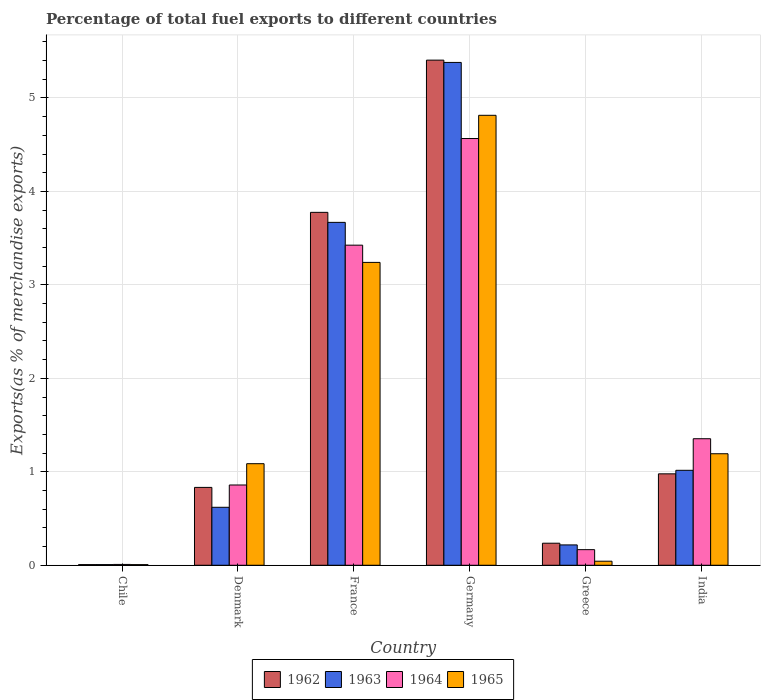How many different coloured bars are there?
Your answer should be compact. 4. Are the number of bars per tick equal to the number of legend labels?
Provide a short and direct response. Yes. Are the number of bars on each tick of the X-axis equal?
Your answer should be compact. Yes. How many bars are there on the 4th tick from the left?
Keep it short and to the point. 4. How many bars are there on the 6th tick from the right?
Provide a short and direct response. 4. What is the label of the 2nd group of bars from the left?
Keep it short and to the point. Denmark. In how many cases, is the number of bars for a given country not equal to the number of legend labels?
Offer a terse response. 0. What is the percentage of exports to different countries in 1962 in Chile?
Keep it short and to the point. 0.01. Across all countries, what is the maximum percentage of exports to different countries in 1964?
Give a very brief answer. 4.57. Across all countries, what is the minimum percentage of exports to different countries in 1962?
Offer a terse response. 0.01. In which country was the percentage of exports to different countries in 1962 maximum?
Give a very brief answer. Germany. What is the total percentage of exports to different countries in 1964 in the graph?
Ensure brevity in your answer.  10.38. What is the difference between the percentage of exports to different countries in 1964 in Chile and that in France?
Give a very brief answer. -3.42. What is the difference between the percentage of exports to different countries in 1965 in Greece and the percentage of exports to different countries in 1964 in India?
Provide a succinct answer. -1.31. What is the average percentage of exports to different countries in 1962 per country?
Provide a succinct answer. 1.87. What is the difference between the percentage of exports to different countries of/in 1965 and percentage of exports to different countries of/in 1962 in France?
Make the answer very short. -0.54. In how many countries, is the percentage of exports to different countries in 1962 greater than 3.4 %?
Your answer should be very brief. 2. What is the ratio of the percentage of exports to different countries in 1965 in France to that in Greece?
Ensure brevity in your answer.  74.69. Is the percentage of exports to different countries in 1962 in Denmark less than that in Germany?
Provide a short and direct response. Yes. What is the difference between the highest and the second highest percentage of exports to different countries in 1964?
Offer a very short reply. -2.07. What is the difference between the highest and the lowest percentage of exports to different countries in 1965?
Your answer should be compact. 4.81. In how many countries, is the percentage of exports to different countries in 1963 greater than the average percentage of exports to different countries in 1963 taken over all countries?
Your response must be concise. 2. Is the sum of the percentage of exports to different countries in 1963 in France and Germany greater than the maximum percentage of exports to different countries in 1964 across all countries?
Offer a terse response. Yes. What does the 4th bar from the left in Greece represents?
Your answer should be very brief. 1965. What does the 3rd bar from the right in Germany represents?
Offer a terse response. 1963. How many bars are there?
Offer a terse response. 24. Are the values on the major ticks of Y-axis written in scientific E-notation?
Keep it short and to the point. No. Does the graph contain grids?
Your response must be concise. Yes. Where does the legend appear in the graph?
Your answer should be compact. Bottom center. How many legend labels are there?
Make the answer very short. 4. What is the title of the graph?
Keep it short and to the point. Percentage of total fuel exports to different countries. What is the label or title of the Y-axis?
Provide a short and direct response. Exports(as % of merchandise exports). What is the Exports(as % of merchandise exports) in 1962 in Chile?
Keep it short and to the point. 0.01. What is the Exports(as % of merchandise exports) of 1963 in Chile?
Your response must be concise. 0.01. What is the Exports(as % of merchandise exports) of 1964 in Chile?
Give a very brief answer. 0.01. What is the Exports(as % of merchandise exports) of 1965 in Chile?
Offer a very short reply. 0.01. What is the Exports(as % of merchandise exports) in 1962 in Denmark?
Provide a succinct answer. 0.83. What is the Exports(as % of merchandise exports) of 1963 in Denmark?
Offer a terse response. 0.62. What is the Exports(as % of merchandise exports) of 1964 in Denmark?
Ensure brevity in your answer.  0.86. What is the Exports(as % of merchandise exports) of 1965 in Denmark?
Your answer should be very brief. 1.09. What is the Exports(as % of merchandise exports) in 1962 in France?
Your response must be concise. 3.78. What is the Exports(as % of merchandise exports) of 1963 in France?
Provide a short and direct response. 3.67. What is the Exports(as % of merchandise exports) of 1964 in France?
Provide a short and direct response. 3.43. What is the Exports(as % of merchandise exports) of 1965 in France?
Your answer should be compact. 3.24. What is the Exports(as % of merchandise exports) in 1962 in Germany?
Offer a very short reply. 5.4. What is the Exports(as % of merchandise exports) in 1963 in Germany?
Provide a short and direct response. 5.38. What is the Exports(as % of merchandise exports) in 1964 in Germany?
Your answer should be compact. 4.57. What is the Exports(as % of merchandise exports) in 1965 in Germany?
Provide a succinct answer. 4.81. What is the Exports(as % of merchandise exports) in 1962 in Greece?
Ensure brevity in your answer.  0.24. What is the Exports(as % of merchandise exports) of 1963 in Greece?
Ensure brevity in your answer.  0.22. What is the Exports(as % of merchandise exports) in 1964 in Greece?
Make the answer very short. 0.17. What is the Exports(as % of merchandise exports) of 1965 in Greece?
Your answer should be very brief. 0.04. What is the Exports(as % of merchandise exports) of 1962 in India?
Your answer should be compact. 0.98. What is the Exports(as % of merchandise exports) of 1963 in India?
Keep it short and to the point. 1.02. What is the Exports(as % of merchandise exports) of 1964 in India?
Offer a terse response. 1.35. What is the Exports(as % of merchandise exports) of 1965 in India?
Your response must be concise. 1.19. Across all countries, what is the maximum Exports(as % of merchandise exports) in 1962?
Provide a short and direct response. 5.4. Across all countries, what is the maximum Exports(as % of merchandise exports) of 1963?
Your response must be concise. 5.38. Across all countries, what is the maximum Exports(as % of merchandise exports) of 1964?
Offer a very short reply. 4.57. Across all countries, what is the maximum Exports(as % of merchandise exports) of 1965?
Provide a succinct answer. 4.81. Across all countries, what is the minimum Exports(as % of merchandise exports) of 1962?
Ensure brevity in your answer.  0.01. Across all countries, what is the minimum Exports(as % of merchandise exports) of 1963?
Your answer should be compact. 0.01. Across all countries, what is the minimum Exports(as % of merchandise exports) in 1964?
Your answer should be very brief. 0.01. Across all countries, what is the minimum Exports(as % of merchandise exports) in 1965?
Your response must be concise. 0.01. What is the total Exports(as % of merchandise exports) in 1962 in the graph?
Make the answer very short. 11.24. What is the total Exports(as % of merchandise exports) of 1963 in the graph?
Keep it short and to the point. 10.91. What is the total Exports(as % of merchandise exports) of 1964 in the graph?
Provide a short and direct response. 10.38. What is the total Exports(as % of merchandise exports) of 1965 in the graph?
Ensure brevity in your answer.  10.39. What is the difference between the Exports(as % of merchandise exports) of 1962 in Chile and that in Denmark?
Provide a short and direct response. -0.83. What is the difference between the Exports(as % of merchandise exports) of 1963 in Chile and that in Denmark?
Keep it short and to the point. -0.61. What is the difference between the Exports(as % of merchandise exports) of 1964 in Chile and that in Denmark?
Make the answer very short. -0.85. What is the difference between the Exports(as % of merchandise exports) in 1965 in Chile and that in Denmark?
Your answer should be very brief. -1.08. What is the difference between the Exports(as % of merchandise exports) in 1962 in Chile and that in France?
Your answer should be compact. -3.77. What is the difference between the Exports(as % of merchandise exports) in 1963 in Chile and that in France?
Offer a very short reply. -3.66. What is the difference between the Exports(as % of merchandise exports) in 1964 in Chile and that in France?
Give a very brief answer. -3.42. What is the difference between the Exports(as % of merchandise exports) of 1965 in Chile and that in France?
Your answer should be very brief. -3.23. What is the difference between the Exports(as % of merchandise exports) of 1962 in Chile and that in Germany?
Your answer should be compact. -5.4. What is the difference between the Exports(as % of merchandise exports) in 1963 in Chile and that in Germany?
Your response must be concise. -5.37. What is the difference between the Exports(as % of merchandise exports) of 1964 in Chile and that in Germany?
Provide a succinct answer. -4.56. What is the difference between the Exports(as % of merchandise exports) in 1965 in Chile and that in Germany?
Your answer should be compact. -4.81. What is the difference between the Exports(as % of merchandise exports) in 1962 in Chile and that in Greece?
Your answer should be very brief. -0.23. What is the difference between the Exports(as % of merchandise exports) in 1963 in Chile and that in Greece?
Offer a terse response. -0.21. What is the difference between the Exports(as % of merchandise exports) in 1964 in Chile and that in Greece?
Provide a short and direct response. -0.16. What is the difference between the Exports(as % of merchandise exports) of 1965 in Chile and that in Greece?
Offer a terse response. -0.04. What is the difference between the Exports(as % of merchandise exports) in 1962 in Chile and that in India?
Offer a very short reply. -0.97. What is the difference between the Exports(as % of merchandise exports) in 1963 in Chile and that in India?
Give a very brief answer. -1.01. What is the difference between the Exports(as % of merchandise exports) in 1964 in Chile and that in India?
Offer a very short reply. -1.34. What is the difference between the Exports(as % of merchandise exports) of 1965 in Chile and that in India?
Offer a terse response. -1.19. What is the difference between the Exports(as % of merchandise exports) in 1962 in Denmark and that in France?
Offer a terse response. -2.94. What is the difference between the Exports(as % of merchandise exports) in 1963 in Denmark and that in France?
Offer a very short reply. -3.05. What is the difference between the Exports(as % of merchandise exports) in 1964 in Denmark and that in France?
Offer a terse response. -2.57. What is the difference between the Exports(as % of merchandise exports) of 1965 in Denmark and that in France?
Keep it short and to the point. -2.15. What is the difference between the Exports(as % of merchandise exports) in 1962 in Denmark and that in Germany?
Provide a short and direct response. -4.57. What is the difference between the Exports(as % of merchandise exports) in 1963 in Denmark and that in Germany?
Make the answer very short. -4.76. What is the difference between the Exports(as % of merchandise exports) in 1964 in Denmark and that in Germany?
Give a very brief answer. -3.71. What is the difference between the Exports(as % of merchandise exports) in 1965 in Denmark and that in Germany?
Provide a short and direct response. -3.73. What is the difference between the Exports(as % of merchandise exports) of 1962 in Denmark and that in Greece?
Your response must be concise. 0.6. What is the difference between the Exports(as % of merchandise exports) in 1963 in Denmark and that in Greece?
Ensure brevity in your answer.  0.4. What is the difference between the Exports(as % of merchandise exports) in 1964 in Denmark and that in Greece?
Your answer should be very brief. 0.69. What is the difference between the Exports(as % of merchandise exports) in 1965 in Denmark and that in Greece?
Offer a very short reply. 1.04. What is the difference between the Exports(as % of merchandise exports) in 1962 in Denmark and that in India?
Provide a succinct answer. -0.14. What is the difference between the Exports(as % of merchandise exports) in 1963 in Denmark and that in India?
Offer a terse response. -0.4. What is the difference between the Exports(as % of merchandise exports) in 1964 in Denmark and that in India?
Provide a short and direct response. -0.49. What is the difference between the Exports(as % of merchandise exports) in 1965 in Denmark and that in India?
Give a very brief answer. -0.11. What is the difference between the Exports(as % of merchandise exports) of 1962 in France and that in Germany?
Give a very brief answer. -1.63. What is the difference between the Exports(as % of merchandise exports) in 1963 in France and that in Germany?
Keep it short and to the point. -1.71. What is the difference between the Exports(as % of merchandise exports) of 1964 in France and that in Germany?
Ensure brevity in your answer.  -1.14. What is the difference between the Exports(as % of merchandise exports) in 1965 in France and that in Germany?
Make the answer very short. -1.57. What is the difference between the Exports(as % of merchandise exports) of 1962 in France and that in Greece?
Ensure brevity in your answer.  3.54. What is the difference between the Exports(as % of merchandise exports) of 1963 in France and that in Greece?
Your answer should be very brief. 3.45. What is the difference between the Exports(as % of merchandise exports) of 1964 in France and that in Greece?
Keep it short and to the point. 3.26. What is the difference between the Exports(as % of merchandise exports) of 1965 in France and that in Greece?
Ensure brevity in your answer.  3.2. What is the difference between the Exports(as % of merchandise exports) of 1962 in France and that in India?
Offer a very short reply. 2.8. What is the difference between the Exports(as % of merchandise exports) of 1963 in France and that in India?
Ensure brevity in your answer.  2.65. What is the difference between the Exports(as % of merchandise exports) of 1964 in France and that in India?
Your answer should be compact. 2.07. What is the difference between the Exports(as % of merchandise exports) in 1965 in France and that in India?
Your answer should be compact. 2.05. What is the difference between the Exports(as % of merchandise exports) of 1962 in Germany and that in Greece?
Provide a short and direct response. 5.17. What is the difference between the Exports(as % of merchandise exports) of 1963 in Germany and that in Greece?
Give a very brief answer. 5.16. What is the difference between the Exports(as % of merchandise exports) in 1964 in Germany and that in Greece?
Provide a short and direct response. 4.4. What is the difference between the Exports(as % of merchandise exports) in 1965 in Germany and that in Greece?
Give a very brief answer. 4.77. What is the difference between the Exports(as % of merchandise exports) in 1962 in Germany and that in India?
Offer a terse response. 4.43. What is the difference between the Exports(as % of merchandise exports) in 1963 in Germany and that in India?
Provide a short and direct response. 4.36. What is the difference between the Exports(as % of merchandise exports) of 1964 in Germany and that in India?
Provide a short and direct response. 3.21. What is the difference between the Exports(as % of merchandise exports) of 1965 in Germany and that in India?
Provide a succinct answer. 3.62. What is the difference between the Exports(as % of merchandise exports) of 1962 in Greece and that in India?
Make the answer very short. -0.74. What is the difference between the Exports(as % of merchandise exports) of 1963 in Greece and that in India?
Make the answer very short. -0.8. What is the difference between the Exports(as % of merchandise exports) in 1964 in Greece and that in India?
Ensure brevity in your answer.  -1.19. What is the difference between the Exports(as % of merchandise exports) of 1965 in Greece and that in India?
Offer a terse response. -1.15. What is the difference between the Exports(as % of merchandise exports) in 1962 in Chile and the Exports(as % of merchandise exports) in 1963 in Denmark?
Your answer should be compact. -0.61. What is the difference between the Exports(as % of merchandise exports) of 1962 in Chile and the Exports(as % of merchandise exports) of 1964 in Denmark?
Provide a succinct answer. -0.85. What is the difference between the Exports(as % of merchandise exports) in 1962 in Chile and the Exports(as % of merchandise exports) in 1965 in Denmark?
Your response must be concise. -1.08. What is the difference between the Exports(as % of merchandise exports) of 1963 in Chile and the Exports(as % of merchandise exports) of 1964 in Denmark?
Offer a terse response. -0.85. What is the difference between the Exports(as % of merchandise exports) in 1963 in Chile and the Exports(as % of merchandise exports) in 1965 in Denmark?
Make the answer very short. -1.08. What is the difference between the Exports(as % of merchandise exports) in 1964 in Chile and the Exports(as % of merchandise exports) in 1965 in Denmark?
Your response must be concise. -1.08. What is the difference between the Exports(as % of merchandise exports) of 1962 in Chile and the Exports(as % of merchandise exports) of 1963 in France?
Offer a terse response. -3.66. What is the difference between the Exports(as % of merchandise exports) in 1962 in Chile and the Exports(as % of merchandise exports) in 1964 in France?
Give a very brief answer. -3.42. What is the difference between the Exports(as % of merchandise exports) in 1962 in Chile and the Exports(as % of merchandise exports) in 1965 in France?
Offer a very short reply. -3.23. What is the difference between the Exports(as % of merchandise exports) in 1963 in Chile and the Exports(as % of merchandise exports) in 1964 in France?
Keep it short and to the point. -3.42. What is the difference between the Exports(as % of merchandise exports) of 1963 in Chile and the Exports(as % of merchandise exports) of 1965 in France?
Keep it short and to the point. -3.23. What is the difference between the Exports(as % of merchandise exports) of 1964 in Chile and the Exports(as % of merchandise exports) of 1965 in France?
Keep it short and to the point. -3.23. What is the difference between the Exports(as % of merchandise exports) of 1962 in Chile and the Exports(as % of merchandise exports) of 1963 in Germany?
Ensure brevity in your answer.  -5.37. What is the difference between the Exports(as % of merchandise exports) of 1962 in Chile and the Exports(as % of merchandise exports) of 1964 in Germany?
Keep it short and to the point. -4.56. What is the difference between the Exports(as % of merchandise exports) in 1962 in Chile and the Exports(as % of merchandise exports) in 1965 in Germany?
Ensure brevity in your answer.  -4.81. What is the difference between the Exports(as % of merchandise exports) in 1963 in Chile and the Exports(as % of merchandise exports) in 1964 in Germany?
Offer a terse response. -4.56. What is the difference between the Exports(as % of merchandise exports) in 1963 in Chile and the Exports(as % of merchandise exports) in 1965 in Germany?
Your answer should be compact. -4.81. What is the difference between the Exports(as % of merchandise exports) of 1964 in Chile and the Exports(as % of merchandise exports) of 1965 in Germany?
Offer a very short reply. -4.81. What is the difference between the Exports(as % of merchandise exports) in 1962 in Chile and the Exports(as % of merchandise exports) in 1963 in Greece?
Make the answer very short. -0.21. What is the difference between the Exports(as % of merchandise exports) of 1962 in Chile and the Exports(as % of merchandise exports) of 1964 in Greece?
Offer a terse response. -0.16. What is the difference between the Exports(as % of merchandise exports) of 1962 in Chile and the Exports(as % of merchandise exports) of 1965 in Greece?
Offer a very short reply. -0.04. What is the difference between the Exports(as % of merchandise exports) in 1963 in Chile and the Exports(as % of merchandise exports) in 1964 in Greece?
Provide a short and direct response. -0.16. What is the difference between the Exports(as % of merchandise exports) of 1963 in Chile and the Exports(as % of merchandise exports) of 1965 in Greece?
Give a very brief answer. -0.04. What is the difference between the Exports(as % of merchandise exports) of 1964 in Chile and the Exports(as % of merchandise exports) of 1965 in Greece?
Ensure brevity in your answer.  -0.03. What is the difference between the Exports(as % of merchandise exports) of 1962 in Chile and the Exports(as % of merchandise exports) of 1963 in India?
Your response must be concise. -1.01. What is the difference between the Exports(as % of merchandise exports) in 1962 in Chile and the Exports(as % of merchandise exports) in 1964 in India?
Give a very brief answer. -1.35. What is the difference between the Exports(as % of merchandise exports) of 1962 in Chile and the Exports(as % of merchandise exports) of 1965 in India?
Provide a succinct answer. -1.19. What is the difference between the Exports(as % of merchandise exports) of 1963 in Chile and the Exports(as % of merchandise exports) of 1964 in India?
Offer a terse response. -1.35. What is the difference between the Exports(as % of merchandise exports) in 1963 in Chile and the Exports(as % of merchandise exports) in 1965 in India?
Ensure brevity in your answer.  -1.19. What is the difference between the Exports(as % of merchandise exports) of 1964 in Chile and the Exports(as % of merchandise exports) of 1965 in India?
Provide a succinct answer. -1.18. What is the difference between the Exports(as % of merchandise exports) in 1962 in Denmark and the Exports(as % of merchandise exports) in 1963 in France?
Your answer should be compact. -2.84. What is the difference between the Exports(as % of merchandise exports) in 1962 in Denmark and the Exports(as % of merchandise exports) in 1964 in France?
Keep it short and to the point. -2.59. What is the difference between the Exports(as % of merchandise exports) in 1962 in Denmark and the Exports(as % of merchandise exports) in 1965 in France?
Ensure brevity in your answer.  -2.41. What is the difference between the Exports(as % of merchandise exports) of 1963 in Denmark and the Exports(as % of merchandise exports) of 1964 in France?
Provide a short and direct response. -2.8. What is the difference between the Exports(as % of merchandise exports) in 1963 in Denmark and the Exports(as % of merchandise exports) in 1965 in France?
Keep it short and to the point. -2.62. What is the difference between the Exports(as % of merchandise exports) of 1964 in Denmark and the Exports(as % of merchandise exports) of 1965 in France?
Keep it short and to the point. -2.38. What is the difference between the Exports(as % of merchandise exports) of 1962 in Denmark and the Exports(as % of merchandise exports) of 1963 in Germany?
Give a very brief answer. -4.55. What is the difference between the Exports(as % of merchandise exports) of 1962 in Denmark and the Exports(as % of merchandise exports) of 1964 in Germany?
Your answer should be very brief. -3.73. What is the difference between the Exports(as % of merchandise exports) in 1962 in Denmark and the Exports(as % of merchandise exports) in 1965 in Germany?
Provide a short and direct response. -3.98. What is the difference between the Exports(as % of merchandise exports) in 1963 in Denmark and the Exports(as % of merchandise exports) in 1964 in Germany?
Your response must be concise. -3.95. What is the difference between the Exports(as % of merchandise exports) in 1963 in Denmark and the Exports(as % of merchandise exports) in 1965 in Germany?
Your response must be concise. -4.19. What is the difference between the Exports(as % of merchandise exports) in 1964 in Denmark and the Exports(as % of merchandise exports) in 1965 in Germany?
Keep it short and to the point. -3.96. What is the difference between the Exports(as % of merchandise exports) of 1962 in Denmark and the Exports(as % of merchandise exports) of 1963 in Greece?
Your answer should be very brief. 0.62. What is the difference between the Exports(as % of merchandise exports) of 1962 in Denmark and the Exports(as % of merchandise exports) of 1964 in Greece?
Ensure brevity in your answer.  0.67. What is the difference between the Exports(as % of merchandise exports) of 1962 in Denmark and the Exports(as % of merchandise exports) of 1965 in Greece?
Your answer should be very brief. 0.79. What is the difference between the Exports(as % of merchandise exports) of 1963 in Denmark and the Exports(as % of merchandise exports) of 1964 in Greece?
Offer a terse response. 0.45. What is the difference between the Exports(as % of merchandise exports) in 1963 in Denmark and the Exports(as % of merchandise exports) in 1965 in Greece?
Your answer should be compact. 0.58. What is the difference between the Exports(as % of merchandise exports) of 1964 in Denmark and the Exports(as % of merchandise exports) of 1965 in Greece?
Make the answer very short. 0.82. What is the difference between the Exports(as % of merchandise exports) of 1962 in Denmark and the Exports(as % of merchandise exports) of 1963 in India?
Provide a succinct answer. -0.18. What is the difference between the Exports(as % of merchandise exports) in 1962 in Denmark and the Exports(as % of merchandise exports) in 1964 in India?
Your answer should be very brief. -0.52. What is the difference between the Exports(as % of merchandise exports) of 1962 in Denmark and the Exports(as % of merchandise exports) of 1965 in India?
Make the answer very short. -0.36. What is the difference between the Exports(as % of merchandise exports) in 1963 in Denmark and the Exports(as % of merchandise exports) in 1964 in India?
Your response must be concise. -0.73. What is the difference between the Exports(as % of merchandise exports) of 1963 in Denmark and the Exports(as % of merchandise exports) of 1965 in India?
Your answer should be very brief. -0.57. What is the difference between the Exports(as % of merchandise exports) of 1964 in Denmark and the Exports(as % of merchandise exports) of 1965 in India?
Ensure brevity in your answer.  -0.33. What is the difference between the Exports(as % of merchandise exports) of 1962 in France and the Exports(as % of merchandise exports) of 1963 in Germany?
Ensure brevity in your answer.  -1.6. What is the difference between the Exports(as % of merchandise exports) of 1962 in France and the Exports(as % of merchandise exports) of 1964 in Germany?
Keep it short and to the point. -0.79. What is the difference between the Exports(as % of merchandise exports) of 1962 in France and the Exports(as % of merchandise exports) of 1965 in Germany?
Keep it short and to the point. -1.04. What is the difference between the Exports(as % of merchandise exports) of 1963 in France and the Exports(as % of merchandise exports) of 1964 in Germany?
Your response must be concise. -0.9. What is the difference between the Exports(as % of merchandise exports) in 1963 in France and the Exports(as % of merchandise exports) in 1965 in Germany?
Provide a short and direct response. -1.15. What is the difference between the Exports(as % of merchandise exports) of 1964 in France and the Exports(as % of merchandise exports) of 1965 in Germany?
Provide a succinct answer. -1.39. What is the difference between the Exports(as % of merchandise exports) in 1962 in France and the Exports(as % of merchandise exports) in 1963 in Greece?
Give a very brief answer. 3.56. What is the difference between the Exports(as % of merchandise exports) in 1962 in France and the Exports(as % of merchandise exports) in 1964 in Greece?
Offer a very short reply. 3.61. What is the difference between the Exports(as % of merchandise exports) in 1962 in France and the Exports(as % of merchandise exports) in 1965 in Greece?
Keep it short and to the point. 3.73. What is the difference between the Exports(as % of merchandise exports) in 1963 in France and the Exports(as % of merchandise exports) in 1964 in Greece?
Provide a succinct answer. 3.5. What is the difference between the Exports(as % of merchandise exports) in 1963 in France and the Exports(as % of merchandise exports) in 1965 in Greece?
Your answer should be very brief. 3.63. What is the difference between the Exports(as % of merchandise exports) of 1964 in France and the Exports(as % of merchandise exports) of 1965 in Greece?
Make the answer very short. 3.38. What is the difference between the Exports(as % of merchandise exports) of 1962 in France and the Exports(as % of merchandise exports) of 1963 in India?
Offer a terse response. 2.76. What is the difference between the Exports(as % of merchandise exports) in 1962 in France and the Exports(as % of merchandise exports) in 1964 in India?
Ensure brevity in your answer.  2.42. What is the difference between the Exports(as % of merchandise exports) of 1962 in France and the Exports(as % of merchandise exports) of 1965 in India?
Provide a short and direct response. 2.58. What is the difference between the Exports(as % of merchandise exports) of 1963 in France and the Exports(as % of merchandise exports) of 1964 in India?
Your answer should be compact. 2.32. What is the difference between the Exports(as % of merchandise exports) in 1963 in France and the Exports(as % of merchandise exports) in 1965 in India?
Your answer should be compact. 2.48. What is the difference between the Exports(as % of merchandise exports) of 1964 in France and the Exports(as % of merchandise exports) of 1965 in India?
Keep it short and to the point. 2.23. What is the difference between the Exports(as % of merchandise exports) of 1962 in Germany and the Exports(as % of merchandise exports) of 1963 in Greece?
Your answer should be compact. 5.19. What is the difference between the Exports(as % of merchandise exports) in 1962 in Germany and the Exports(as % of merchandise exports) in 1964 in Greece?
Your response must be concise. 5.24. What is the difference between the Exports(as % of merchandise exports) of 1962 in Germany and the Exports(as % of merchandise exports) of 1965 in Greece?
Provide a succinct answer. 5.36. What is the difference between the Exports(as % of merchandise exports) of 1963 in Germany and the Exports(as % of merchandise exports) of 1964 in Greece?
Your response must be concise. 5.21. What is the difference between the Exports(as % of merchandise exports) in 1963 in Germany and the Exports(as % of merchandise exports) in 1965 in Greece?
Provide a short and direct response. 5.34. What is the difference between the Exports(as % of merchandise exports) in 1964 in Germany and the Exports(as % of merchandise exports) in 1965 in Greece?
Make the answer very short. 4.52. What is the difference between the Exports(as % of merchandise exports) in 1962 in Germany and the Exports(as % of merchandise exports) in 1963 in India?
Offer a terse response. 4.39. What is the difference between the Exports(as % of merchandise exports) of 1962 in Germany and the Exports(as % of merchandise exports) of 1964 in India?
Provide a short and direct response. 4.05. What is the difference between the Exports(as % of merchandise exports) of 1962 in Germany and the Exports(as % of merchandise exports) of 1965 in India?
Provide a succinct answer. 4.21. What is the difference between the Exports(as % of merchandise exports) in 1963 in Germany and the Exports(as % of merchandise exports) in 1964 in India?
Offer a terse response. 4.03. What is the difference between the Exports(as % of merchandise exports) of 1963 in Germany and the Exports(as % of merchandise exports) of 1965 in India?
Ensure brevity in your answer.  4.19. What is the difference between the Exports(as % of merchandise exports) of 1964 in Germany and the Exports(as % of merchandise exports) of 1965 in India?
Give a very brief answer. 3.37. What is the difference between the Exports(as % of merchandise exports) in 1962 in Greece and the Exports(as % of merchandise exports) in 1963 in India?
Your answer should be very brief. -0.78. What is the difference between the Exports(as % of merchandise exports) in 1962 in Greece and the Exports(as % of merchandise exports) in 1964 in India?
Ensure brevity in your answer.  -1.12. What is the difference between the Exports(as % of merchandise exports) in 1962 in Greece and the Exports(as % of merchandise exports) in 1965 in India?
Provide a succinct answer. -0.96. What is the difference between the Exports(as % of merchandise exports) in 1963 in Greece and the Exports(as % of merchandise exports) in 1964 in India?
Provide a succinct answer. -1.14. What is the difference between the Exports(as % of merchandise exports) in 1963 in Greece and the Exports(as % of merchandise exports) in 1965 in India?
Make the answer very short. -0.98. What is the difference between the Exports(as % of merchandise exports) of 1964 in Greece and the Exports(as % of merchandise exports) of 1965 in India?
Give a very brief answer. -1.03. What is the average Exports(as % of merchandise exports) of 1962 per country?
Your response must be concise. 1.87. What is the average Exports(as % of merchandise exports) in 1963 per country?
Your answer should be compact. 1.82. What is the average Exports(as % of merchandise exports) in 1964 per country?
Offer a terse response. 1.73. What is the average Exports(as % of merchandise exports) of 1965 per country?
Provide a succinct answer. 1.73. What is the difference between the Exports(as % of merchandise exports) of 1962 and Exports(as % of merchandise exports) of 1963 in Chile?
Your response must be concise. -0. What is the difference between the Exports(as % of merchandise exports) in 1962 and Exports(as % of merchandise exports) in 1964 in Chile?
Keep it short and to the point. -0. What is the difference between the Exports(as % of merchandise exports) of 1962 and Exports(as % of merchandise exports) of 1965 in Chile?
Your answer should be compact. 0. What is the difference between the Exports(as % of merchandise exports) of 1963 and Exports(as % of merchandise exports) of 1964 in Chile?
Offer a very short reply. -0. What is the difference between the Exports(as % of merchandise exports) of 1964 and Exports(as % of merchandise exports) of 1965 in Chile?
Your answer should be compact. 0. What is the difference between the Exports(as % of merchandise exports) of 1962 and Exports(as % of merchandise exports) of 1963 in Denmark?
Offer a terse response. 0.21. What is the difference between the Exports(as % of merchandise exports) in 1962 and Exports(as % of merchandise exports) in 1964 in Denmark?
Your answer should be very brief. -0.03. What is the difference between the Exports(as % of merchandise exports) in 1962 and Exports(as % of merchandise exports) in 1965 in Denmark?
Provide a succinct answer. -0.25. What is the difference between the Exports(as % of merchandise exports) in 1963 and Exports(as % of merchandise exports) in 1964 in Denmark?
Your answer should be very brief. -0.24. What is the difference between the Exports(as % of merchandise exports) of 1963 and Exports(as % of merchandise exports) of 1965 in Denmark?
Keep it short and to the point. -0.47. What is the difference between the Exports(as % of merchandise exports) of 1964 and Exports(as % of merchandise exports) of 1965 in Denmark?
Give a very brief answer. -0.23. What is the difference between the Exports(as % of merchandise exports) in 1962 and Exports(as % of merchandise exports) in 1963 in France?
Your answer should be very brief. 0.11. What is the difference between the Exports(as % of merchandise exports) in 1962 and Exports(as % of merchandise exports) in 1964 in France?
Your answer should be compact. 0.35. What is the difference between the Exports(as % of merchandise exports) in 1962 and Exports(as % of merchandise exports) in 1965 in France?
Give a very brief answer. 0.54. What is the difference between the Exports(as % of merchandise exports) in 1963 and Exports(as % of merchandise exports) in 1964 in France?
Give a very brief answer. 0.24. What is the difference between the Exports(as % of merchandise exports) in 1963 and Exports(as % of merchandise exports) in 1965 in France?
Make the answer very short. 0.43. What is the difference between the Exports(as % of merchandise exports) of 1964 and Exports(as % of merchandise exports) of 1965 in France?
Provide a short and direct response. 0.18. What is the difference between the Exports(as % of merchandise exports) in 1962 and Exports(as % of merchandise exports) in 1963 in Germany?
Your answer should be compact. 0.02. What is the difference between the Exports(as % of merchandise exports) of 1962 and Exports(as % of merchandise exports) of 1964 in Germany?
Make the answer very short. 0.84. What is the difference between the Exports(as % of merchandise exports) of 1962 and Exports(as % of merchandise exports) of 1965 in Germany?
Ensure brevity in your answer.  0.59. What is the difference between the Exports(as % of merchandise exports) of 1963 and Exports(as % of merchandise exports) of 1964 in Germany?
Your response must be concise. 0.81. What is the difference between the Exports(as % of merchandise exports) in 1963 and Exports(as % of merchandise exports) in 1965 in Germany?
Offer a very short reply. 0.57. What is the difference between the Exports(as % of merchandise exports) in 1964 and Exports(as % of merchandise exports) in 1965 in Germany?
Make the answer very short. -0.25. What is the difference between the Exports(as % of merchandise exports) in 1962 and Exports(as % of merchandise exports) in 1963 in Greece?
Offer a very short reply. 0.02. What is the difference between the Exports(as % of merchandise exports) in 1962 and Exports(as % of merchandise exports) in 1964 in Greece?
Keep it short and to the point. 0.07. What is the difference between the Exports(as % of merchandise exports) of 1962 and Exports(as % of merchandise exports) of 1965 in Greece?
Offer a terse response. 0.19. What is the difference between the Exports(as % of merchandise exports) of 1963 and Exports(as % of merchandise exports) of 1964 in Greece?
Provide a succinct answer. 0.05. What is the difference between the Exports(as % of merchandise exports) of 1963 and Exports(as % of merchandise exports) of 1965 in Greece?
Offer a terse response. 0.17. What is the difference between the Exports(as % of merchandise exports) of 1964 and Exports(as % of merchandise exports) of 1965 in Greece?
Provide a short and direct response. 0.12. What is the difference between the Exports(as % of merchandise exports) of 1962 and Exports(as % of merchandise exports) of 1963 in India?
Your answer should be very brief. -0.04. What is the difference between the Exports(as % of merchandise exports) of 1962 and Exports(as % of merchandise exports) of 1964 in India?
Your answer should be very brief. -0.38. What is the difference between the Exports(as % of merchandise exports) in 1962 and Exports(as % of merchandise exports) in 1965 in India?
Make the answer very short. -0.22. What is the difference between the Exports(as % of merchandise exports) in 1963 and Exports(as % of merchandise exports) in 1964 in India?
Ensure brevity in your answer.  -0.34. What is the difference between the Exports(as % of merchandise exports) in 1963 and Exports(as % of merchandise exports) in 1965 in India?
Your response must be concise. -0.18. What is the difference between the Exports(as % of merchandise exports) of 1964 and Exports(as % of merchandise exports) of 1965 in India?
Ensure brevity in your answer.  0.16. What is the ratio of the Exports(as % of merchandise exports) in 1962 in Chile to that in Denmark?
Ensure brevity in your answer.  0.01. What is the ratio of the Exports(as % of merchandise exports) in 1963 in Chile to that in Denmark?
Offer a very short reply. 0.01. What is the ratio of the Exports(as % of merchandise exports) of 1964 in Chile to that in Denmark?
Your answer should be very brief. 0.01. What is the ratio of the Exports(as % of merchandise exports) in 1965 in Chile to that in Denmark?
Provide a succinct answer. 0.01. What is the ratio of the Exports(as % of merchandise exports) of 1962 in Chile to that in France?
Provide a short and direct response. 0. What is the ratio of the Exports(as % of merchandise exports) of 1963 in Chile to that in France?
Offer a terse response. 0. What is the ratio of the Exports(as % of merchandise exports) in 1964 in Chile to that in France?
Your answer should be compact. 0. What is the ratio of the Exports(as % of merchandise exports) of 1965 in Chile to that in France?
Ensure brevity in your answer.  0. What is the ratio of the Exports(as % of merchandise exports) in 1962 in Chile to that in Germany?
Offer a terse response. 0. What is the ratio of the Exports(as % of merchandise exports) in 1963 in Chile to that in Germany?
Your answer should be very brief. 0. What is the ratio of the Exports(as % of merchandise exports) in 1964 in Chile to that in Germany?
Provide a short and direct response. 0. What is the ratio of the Exports(as % of merchandise exports) of 1965 in Chile to that in Germany?
Your response must be concise. 0. What is the ratio of the Exports(as % of merchandise exports) of 1962 in Chile to that in Greece?
Provide a short and direct response. 0.03. What is the ratio of the Exports(as % of merchandise exports) of 1963 in Chile to that in Greece?
Keep it short and to the point. 0.03. What is the ratio of the Exports(as % of merchandise exports) in 1964 in Chile to that in Greece?
Your answer should be very brief. 0.05. What is the ratio of the Exports(as % of merchandise exports) of 1965 in Chile to that in Greece?
Keep it short and to the point. 0.16. What is the ratio of the Exports(as % of merchandise exports) of 1962 in Chile to that in India?
Make the answer very short. 0.01. What is the ratio of the Exports(as % of merchandise exports) of 1963 in Chile to that in India?
Offer a very short reply. 0.01. What is the ratio of the Exports(as % of merchandise exports) of 1964 in Chile to that in India?
Offer a very short reply. 0.01. What is the ratio of the Exports(as % of merchandise exports) in 1965 in Chile to that in India?
Provide a succinct answer. 0.01. What is the ratio of the Exports(as % of merchandise exports) of 1962 in Denmark to that in France?
Keep it short and to the point. 0.22. What is the ratio of the Exports(as % of merchandise exports) of 1963 in Denmark to that in France?
Make the answer very short. 0.17. What is the ratio of the Exports(as % of merchandise exports) of 1964 in Denmark to that in France?
Provide a short and direct response. 0.25. What is the ratio of the Exports(as % of merchandise exports) of 1965 in Denmark to that in France?
Give a very brief answer. 0.34. What is the ratio of the Exports(as % of merchandise exports) in 1962 in Denmark to that in Germany?
Make the answer very short. 0.15. What is the ratio of the Exports(as % of merchandise exports) of 1963 in Denmark to that in Germany?
Provide a succinct answer. 0.12. What is the ratio of the Exports(as % of merchandise exports) of 1964 in Denmark to that in Germany?
Offer a terse response. 0.19. What is the ratio of the Exports(as % of merchandise exports) in 1965 in Denmark to that in Germany?
Offer a terse response. 0.23. What is the ratio of the Exports(as % of merchandise exports) in 1962 in Denmark to that in Greece?
Make the answer very short. 3.53. What is the ratio of the Exports(as % of merchandise exports) in 1963 in Denmark to that in Greece?
Your answer should be compact. 2.85. What is the ratio of the Exports(as % of merchandise exports) of 1964 in Denmark to that in Greece?
Give a very brief answer. 5.14. What is the ratio of the Exports(as % of merchandise exports) of 1965 in Denmark to that in Greece?
Offer a very short reply. 25.05. What is the ratio of the Exports(as % of merchandise exports) in 1962 in Denmark to that in India?
Your answer should be compact. 0.85. What is the ratio of the Exports(as % of merchandise exports) in 1963 in Denmark to that in India?
Your answer should be very brief. 0.61. What is the ratio of the Exports(as % of merchandise exports) of 1964 in Denmark to that in India?
Offer a terse response. 0.63. What is the ratio of the Exports(as % of merchandise exports) of 1965 in Denmark to that in India?
Provide a short and direct response. 0.91. What is the ratio of the Exports(as % of merchandise exports) of 1962 in France to that in Germany?
Make the answer very short. 0.7. What is the ratio of the Exports(as % of merchandise exports) of 1963 in France to that in Germany?
Offer a very short reply. 0.68. What is the ratio of the Exports(as % of merchandise exports) in 1964 in France to that in Germany?
Make the answer very short. 0.75. What is the ratio of the Exports(as % of merchandise exports) in 1965 in France to that in Germany?
Provide a short and direct response. 0.67. What is the ratio of the Exports(as % of merchandise exports) in 1962 in France to that in Greece?
Your answer should be very brief. 16.01. What is the ratio of the Exports(as % of merchandise exports) in 1963 in France to that in Greece?
Your answer should be very brief. 16.85. What is the ratio of the Exports(as % of merchandise exports) of 1964 in France to that in Greece?
Your response must be concise. 20.5. What is the ratio of the Exports(as % of merchandise exports) of 1965 in France to that in Greece?
Your answer should be compact. 74.69. What is the ratio of the Exports(as % of merchandise exports) of 1962 in France to that in India?
Keep it short and to the point. 3.86. What is the ratio of the Exports(as % of merchandise exports) of 1963 in France to that in India?
Make the answer very short. 3.61. What is the ratio of the Exports(as % of merchandise exports) of 1964 in France to that in India?
Offer a very short reply. 2.53. What is the ratio of the Exports(as % of merchandise exports) of 1965 in France to that in India?
Provide a short and direct response. 2.72. What is the ratio of the Exports(as % of merchandise exports) of 1962 in Germany to that in Greece?
Provide a short and direct response. 22.91. What is the ratio of the Exports(as % of merchandise exports) in 1963 in Germany to that in Greece?
Offer a very short reply. 24.71. What is the ratio of the Exports(as % of merchandise exports) of 1964 in Germany to that in Greece?
Offer a very short reply. 27.34. What is the ratio of the Exports(as % of merchandise exports) of 1965 in Germany to that in Greece?
Keep it short and to the point. 110.96. What is the ratio of the Exports(as % of merchandise exports) of 1962 in Germany to that in India?
Offer a terse response. 5.53. What is the ratio of the Exports(as % of merchandise exports) in 1963 in Germany to that in India?
Offer a very short reply. 5.3. What is the ratio of the Exports(as % of merchandise exports) of 1964 in Germany to that in India?
Your response must be concise. 3.37. What is the ratio of the Exports(as % of merchandise exports) of 1965 in Germany to that in India?
Your response must be concise. 4.03. What is the ratio of the Exports(as % of merchandise exports) in 1962 in Greece to that in India?
Your answer should be very brief. 0.24. What is the ratio of the Exports(as % of merchandise exports) in 1963 in Greece to that in India?
Keep it short and to the point. 0.21. What is the ratio of the Exports(as % of merchandise exports) of 1964 in Greece to that in India?
Provide a short and direct response. 0.12. What is the ratio of the Exports(as % of merchandise exports) of 1965 in Greece to that in India?
Make the answer very short. 0.04. What is the difference between the highest and the second highest Exports(as % of merchandise exports) in 1962?
Offer a terse response. 1.63. What is the difference between the highest and the second highest Exports(as % of merchandise exports) in 1963?
Make the answer very short. 1.71. What is the difference between the highest and the second highest Exports(as % of merchandise exports) in 1964?
Offer a very short reply. 1.14. What is the difference between the highest and the second highest Exports(as % of merchandise exports) of 1965?
Ensure brevity in your answer.  1.57. What is the difference between the highest and the lowest Exports(as % of merchandise exports) of 1962?
Ensure brevity in your answer.  5.4. What is the difference between the highest and the lowest Exports(as % of merchandise exports) of 1963?
Provide a short and direct response. 5.37. What is the difference between the highest and the lowest Exports(as % of merchandise exports) in 1964?
Keep it short and to the point. 4.56. What is the difference between the highest and the lowest Exports(as % of merchandise exports) in 1965?
Offer a terse response. 4.81. 